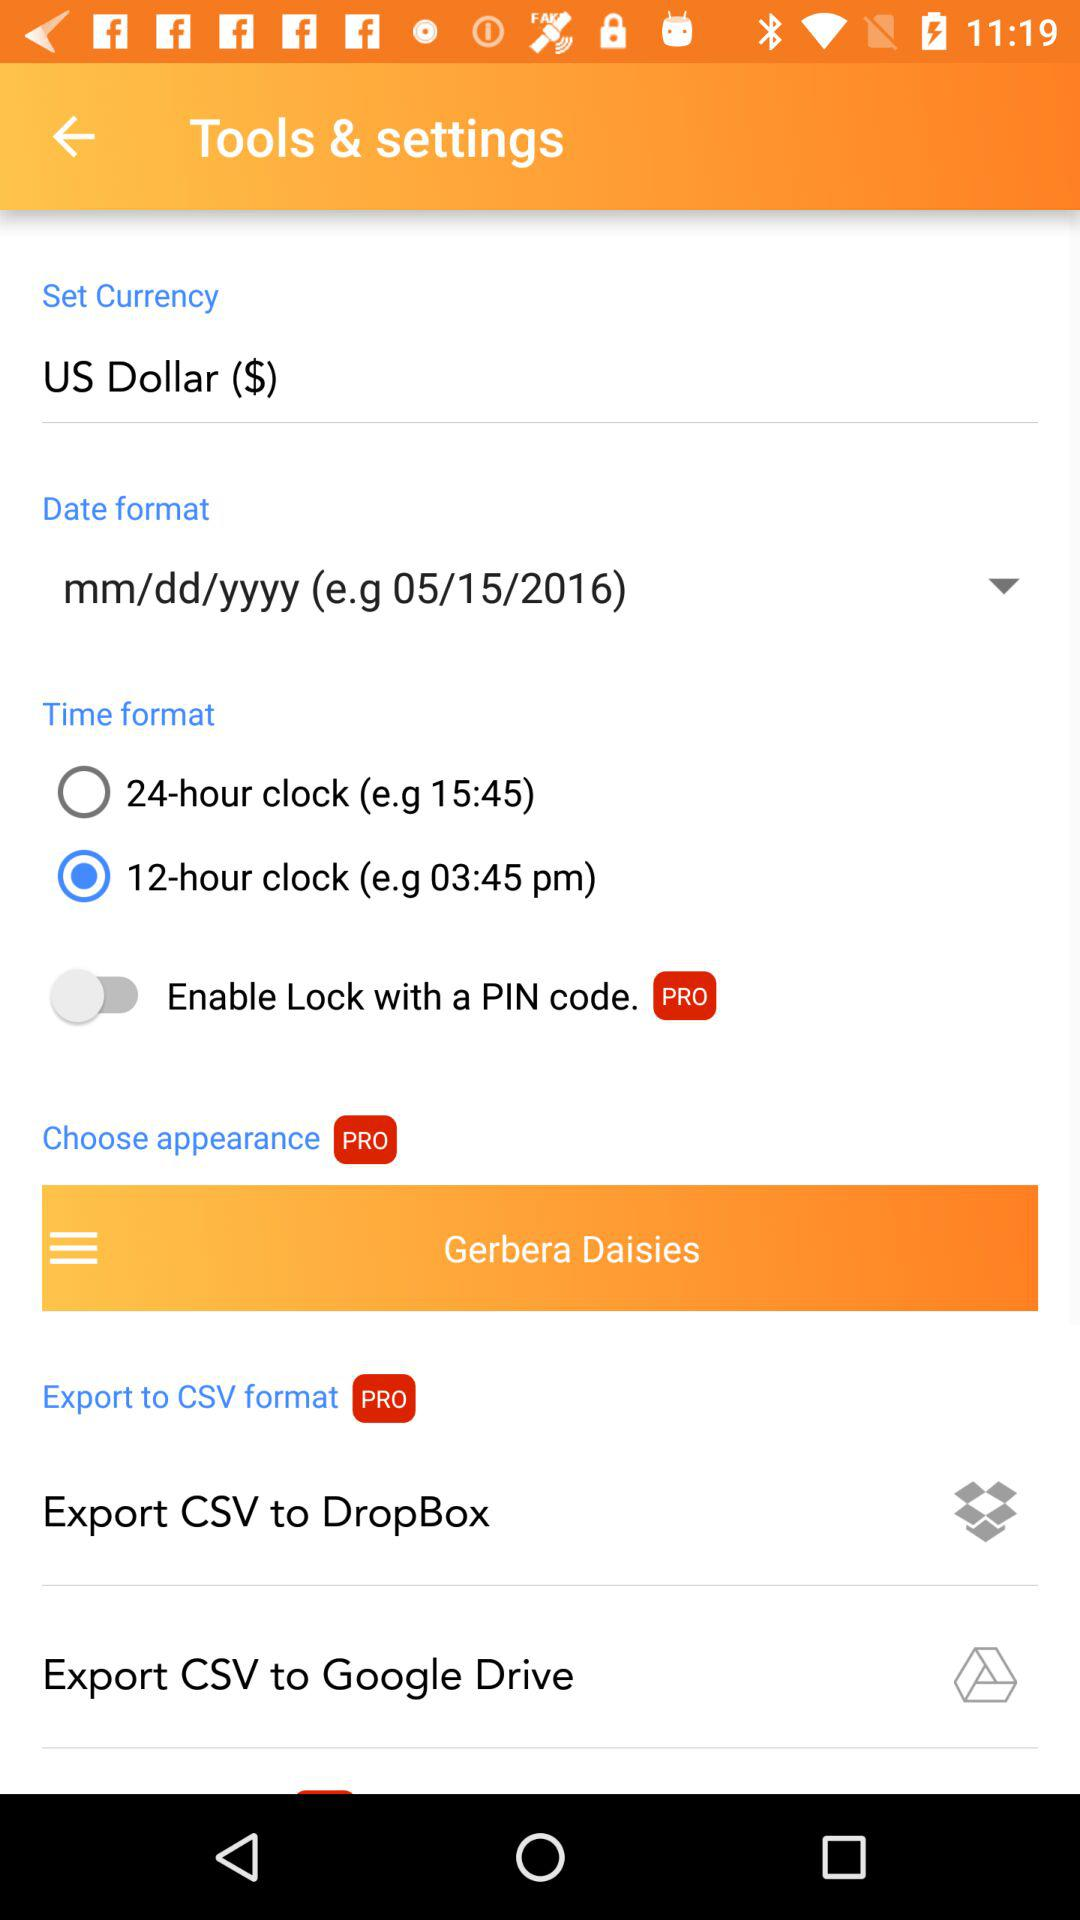What's the status of "Enable Lock with a PIN code"? The status is "off". 